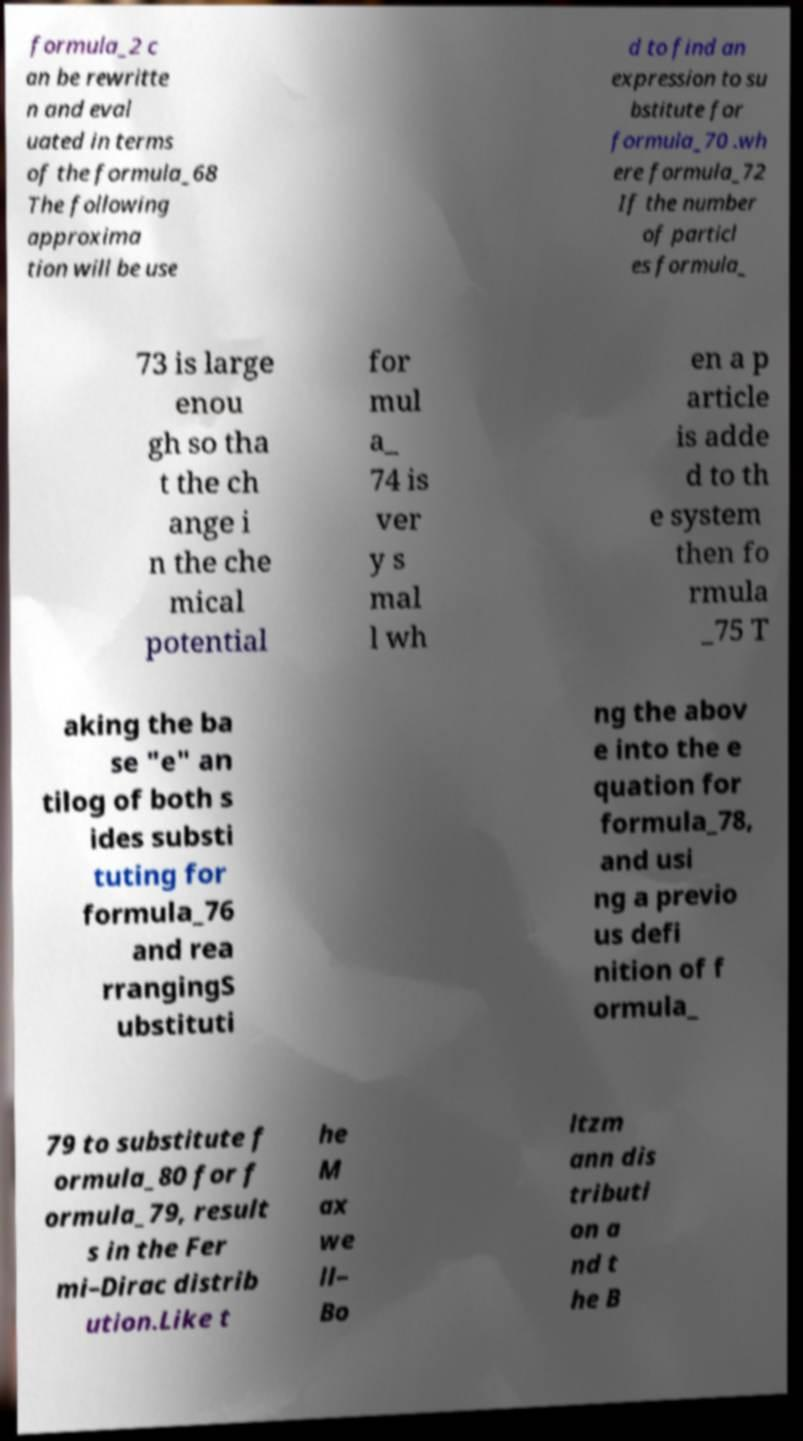Please identify and transcribe the text found in this image. formula_2 c an be rewritte n and eval uated in terms of the formula_68 The following approxima tion will be use d to find an expression to su bstitute for formula_70 .wh ere formula_72 If the number of particl es formula_ 73 is large enou gh so tha t the ch ange i n the che mical potential for mul a_ 74 is ver y s mal l wh en a p article is adde d to th e system then fo rmula _75 T aking the ba se "e" an tilog of both s ides substi tuting for formula_76 and rea rrangingS ubstituti ng the abov e into the e quation for formula_78, and usi ng a previo us defi nition of f ormula_ 79 to substitute f ormula_80 for f ormula_79, result s in the Fer mi–Dirac distrib ution.Like t he M ax we ll– Bo ltzm ann dis tributi on a nd t he B 